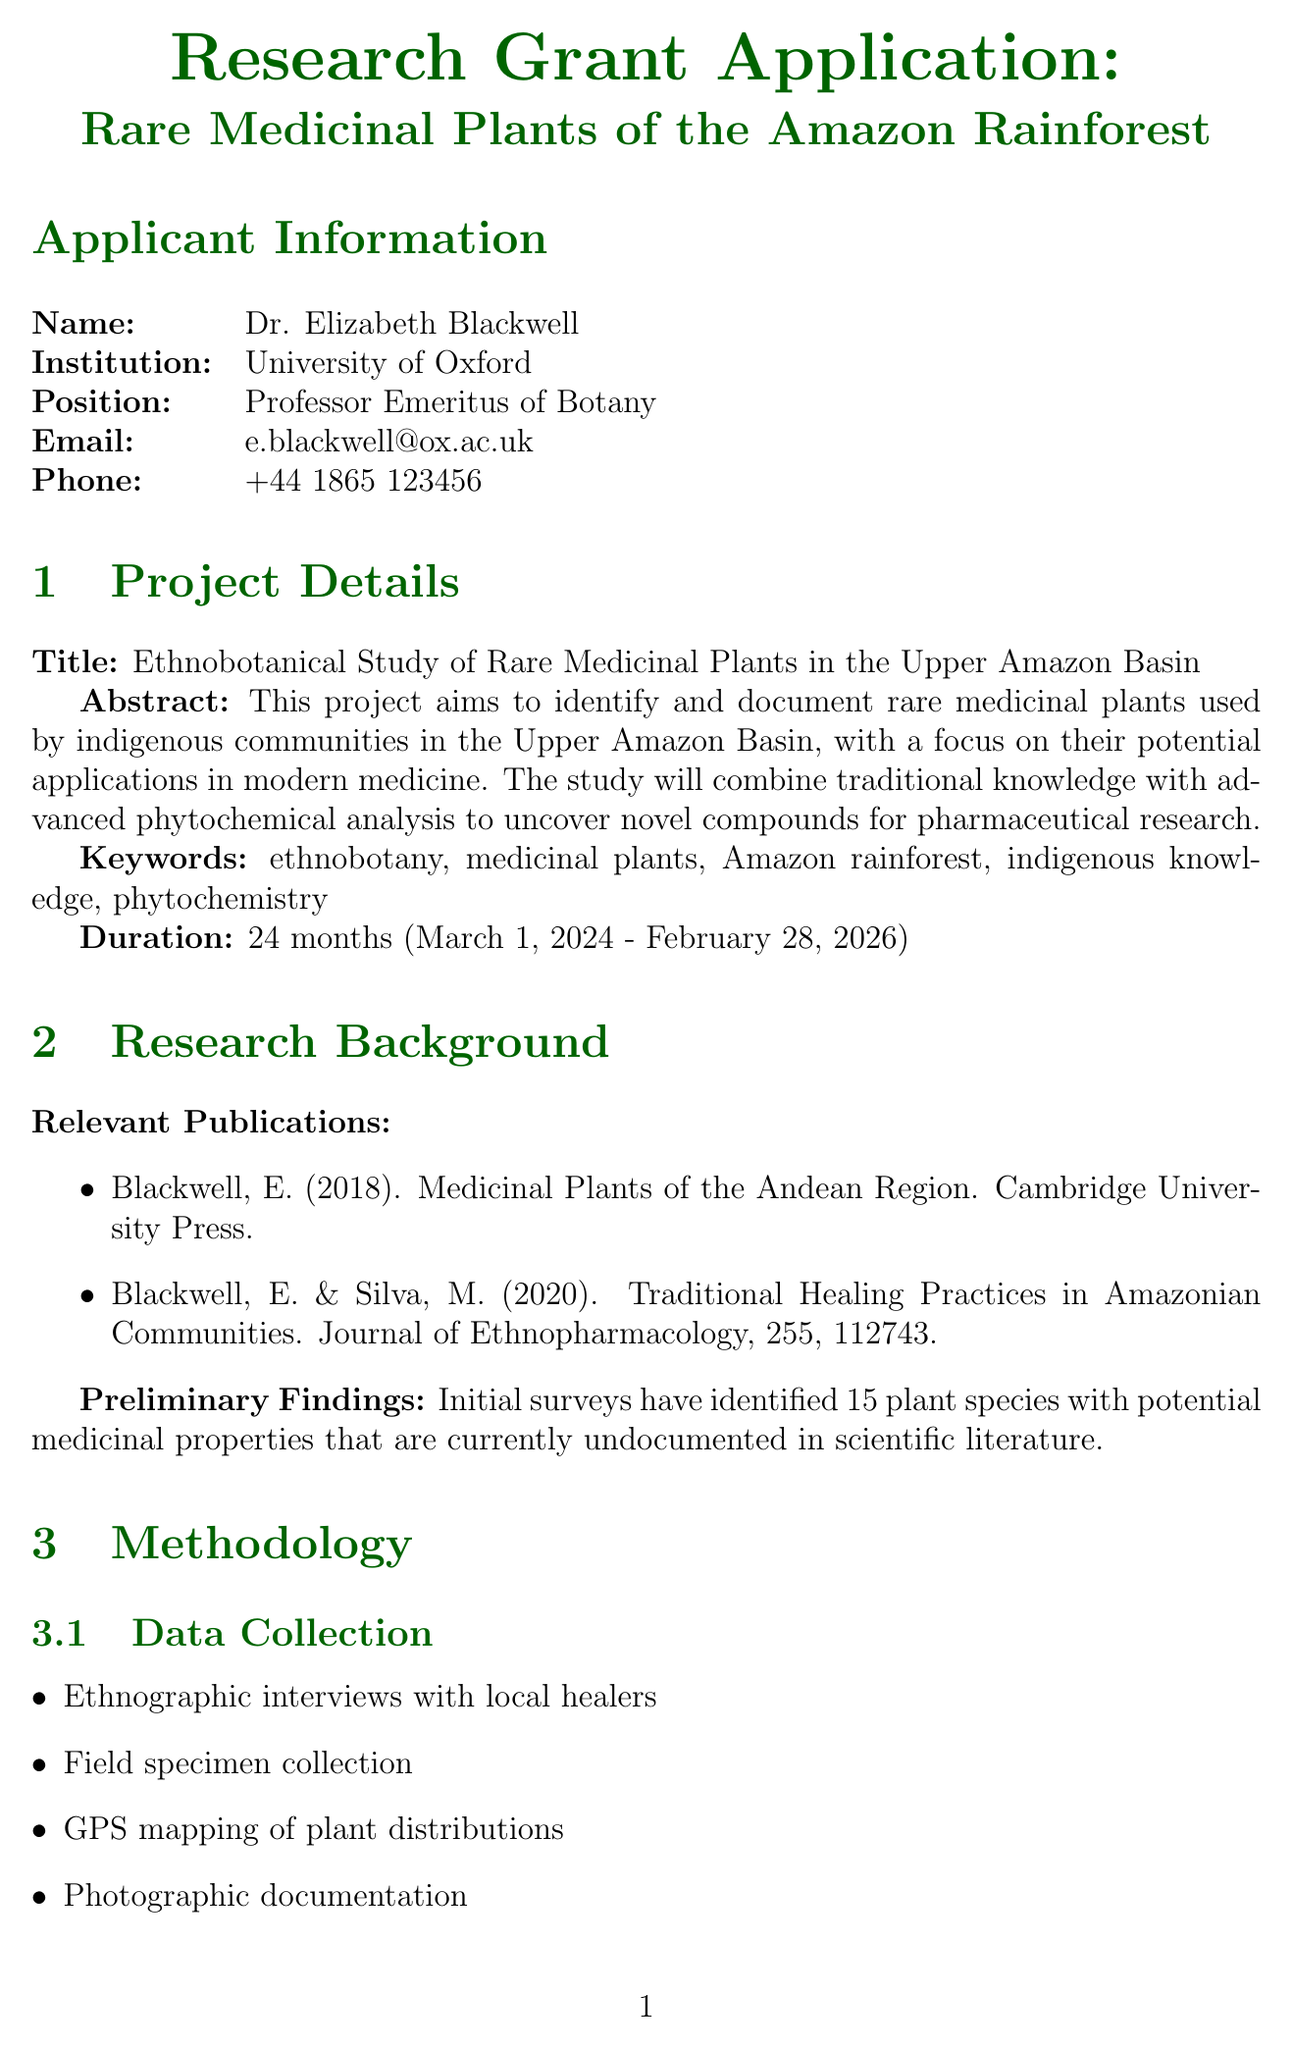what is the title of the project? The title of the project is given in the document under project details.
Answer: Ethnobotanical Study of Rare Medicinal Plants in the Upper Amazon Basin who is the principal investigator? The principal investigator's name is listed in the applicant information section.
Answer: Dr. Elizabeth Blackwell what is the duration of the project? The duration of the project is specified in the project details section.
Answer: 24 months how many months are allocated for field research? The number of months dedicated to field research is detailed in the project timeline.
Answer: 12 months what is the total budget requested for the project? The total budget is presented in the budget summary section of the document.
Answer: 250,000 who is the local research coordinator? The local research coordinator is mentioned in the collaborators section.
Answer: Dr. Carlos Nobre what methodology will be used for data analysis? The methodology for data analysis is listed and includes specific techniques.
Answer: Statistical analysis of ethnobotanical data what is the expected number of peer-reviewed articles to be published? The expected outcomes include a specific number of articles to be published.
Answer: 3-5 which institution had to approve the research? The approvals required are mentioned in the ethical considerations section.
Answer: University of Oxford 